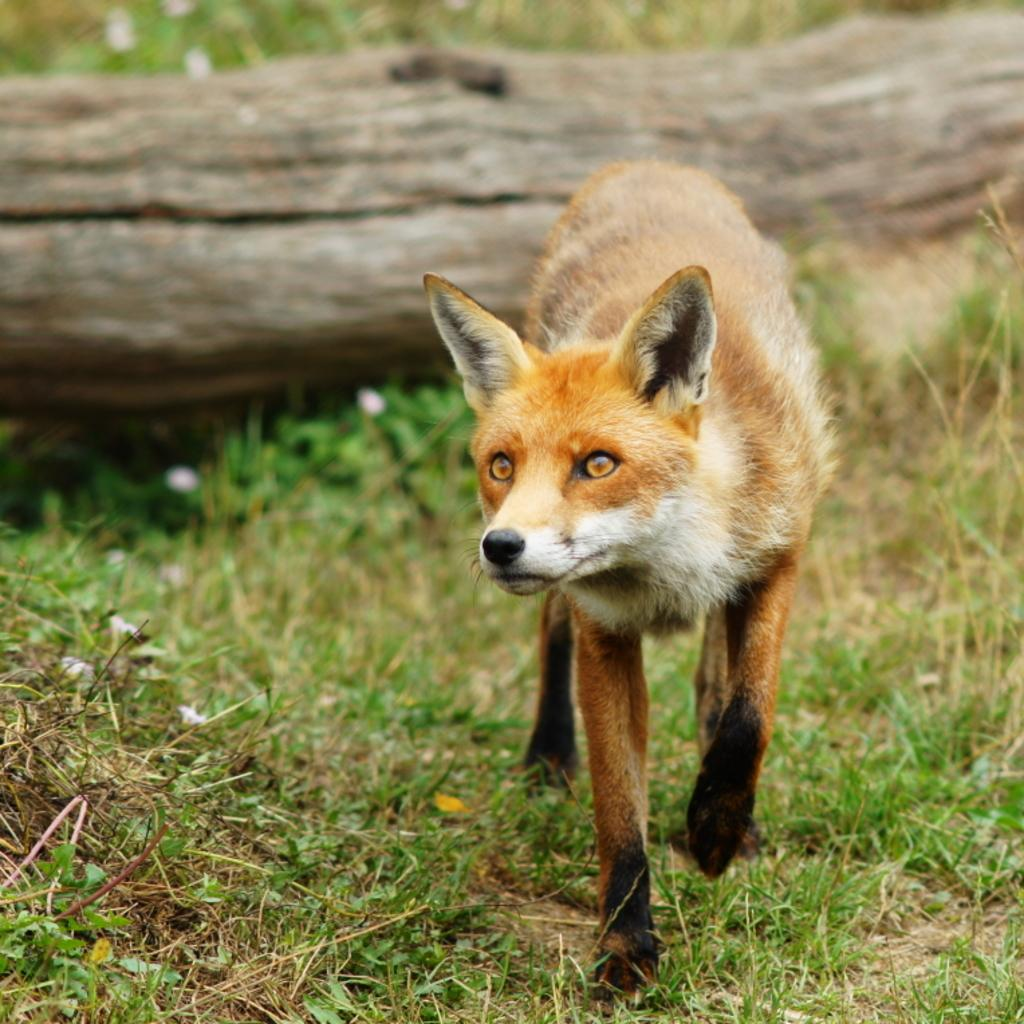What animal is present in the image? There is a fox in the picture. What type of object can be seen in the background of the image? There is a wooden log in the background of the picture. What natural environment is visible in the background of the image? There is grass visible in the background of the picture. What type of form does the son of the fox take in the image? There is no son of the fox present in the image, and therefore no such form can be observed. 